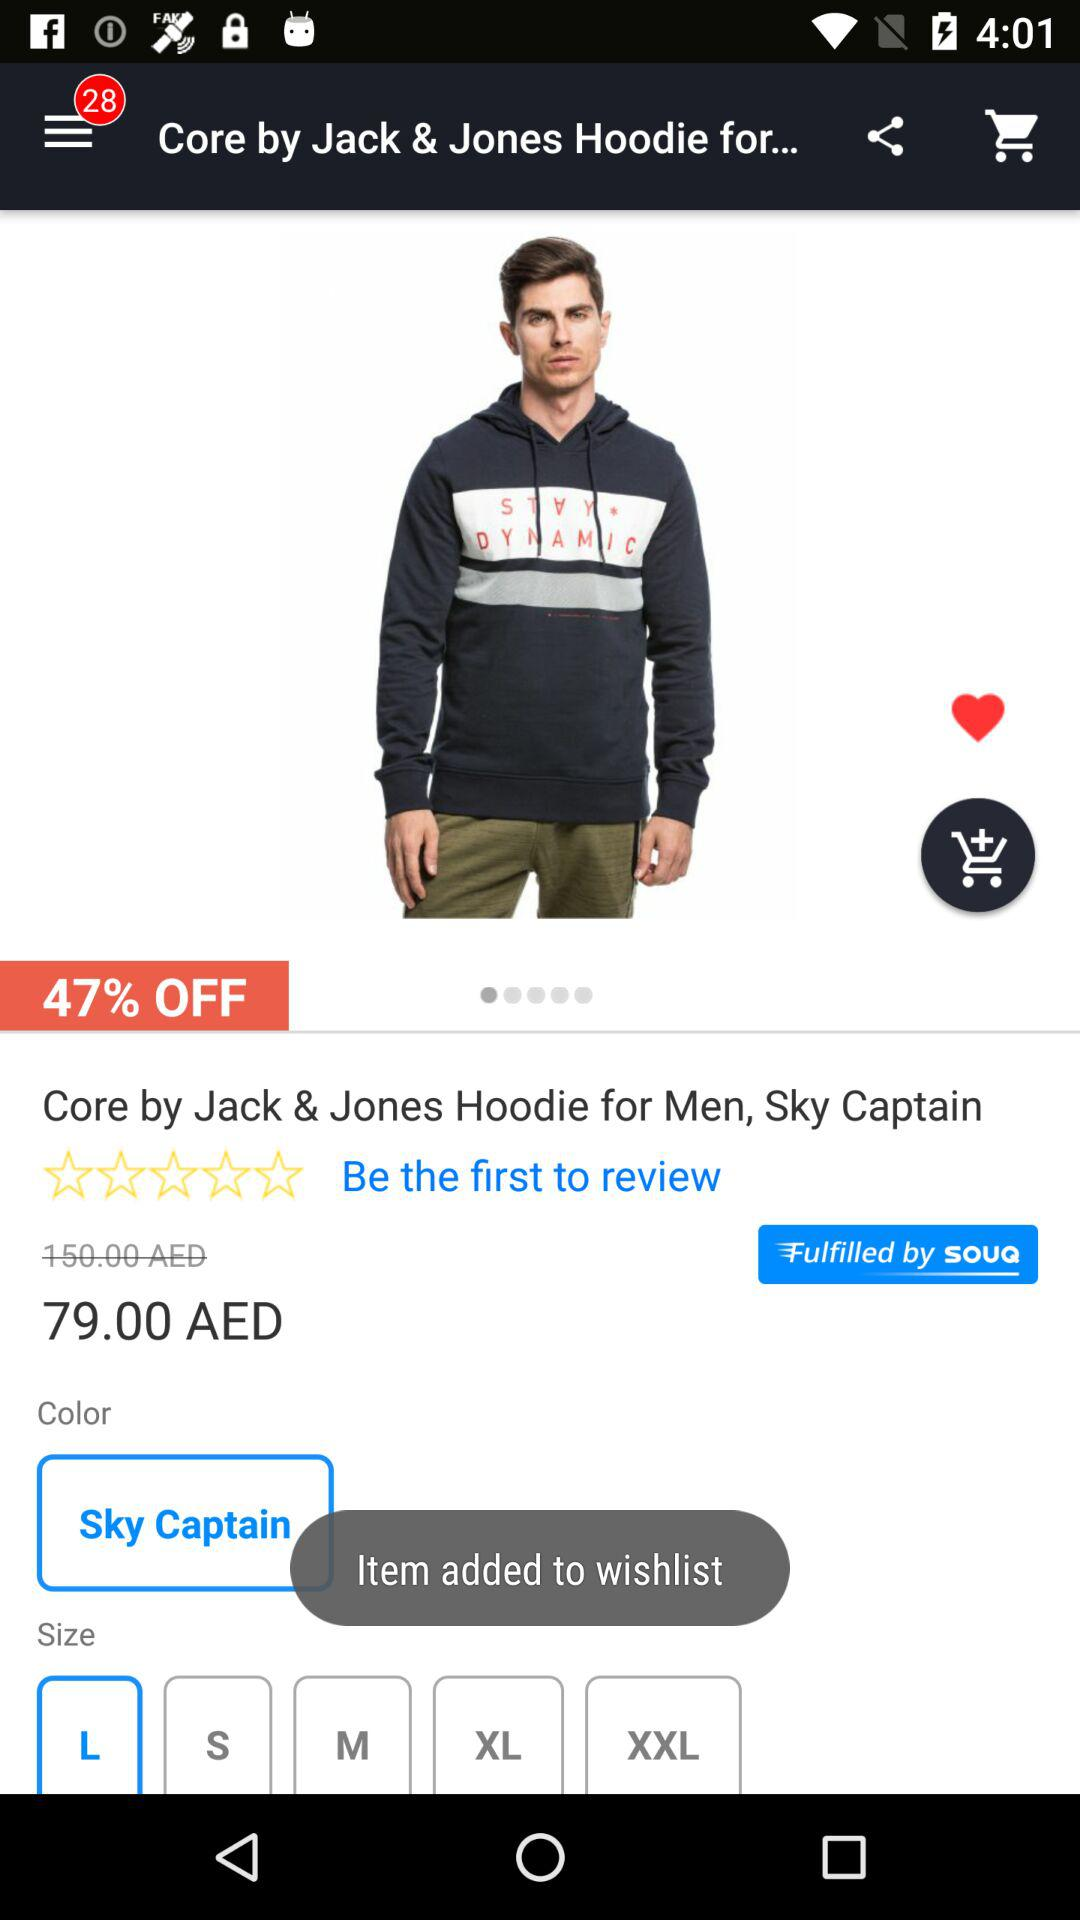How many sizes are available for the product?
Answer the question using a single word or phrase. 5 